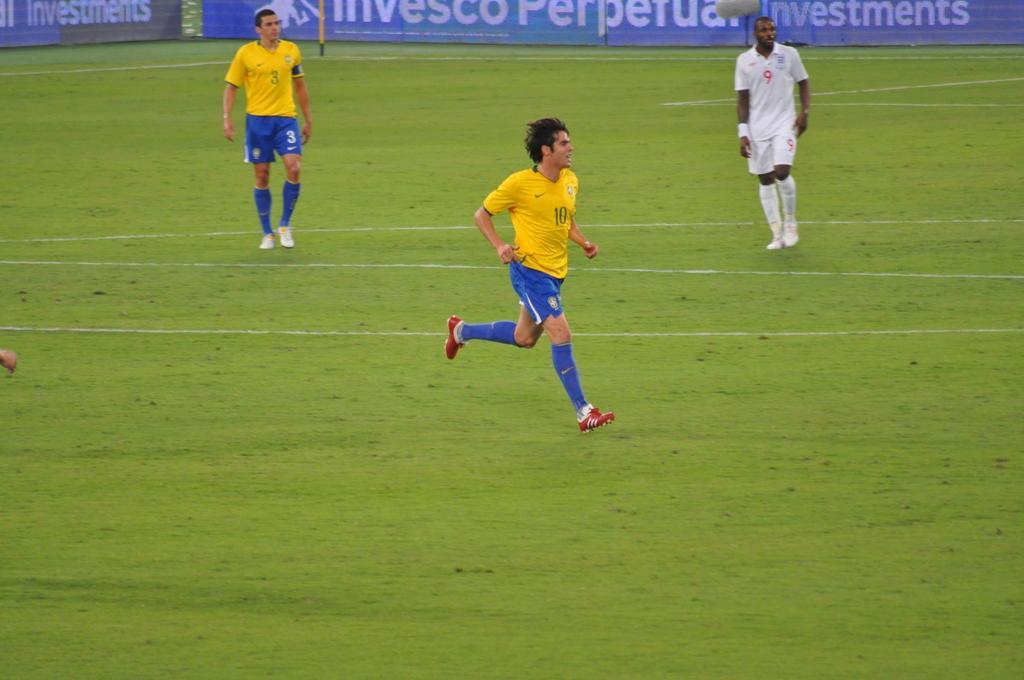Could you give a brief overview of what you see in this image? In this image we can see playground and two players are in yellow color t-shirt and blue color shorts. And one more player is in white color dress. Background of the image blue color banner is present. 